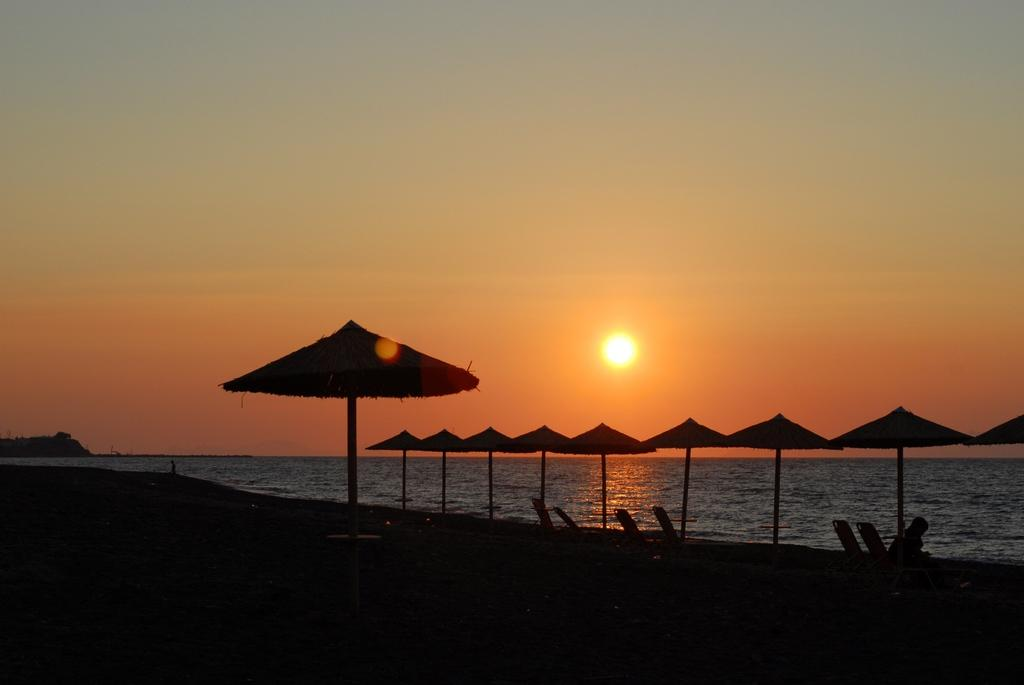What objects are present in the image that can provide shelter from the rain? There are umbrellas in the image that can provide shelter from the rain. What type of furniture is visible in the image? There are chairs in the image. Can you describe the person in the image? There is a person in the image. What can be seen in the background of the image? There is water visible in the background of the image. What is the weather like in the image? The sun is visible in the sky, suggesting a sunny day. What part of the natural environment is visible in the image? The sky is visible in the image. What type of afterthought is the person having while holding the umbrella in the image? There is no indication of any afterthoughts in the image; the person is simply holding an umbrella. Can you tell me what error the person made while setting up the umbrella in the image? There is no error visible in the image; the person is holding an umbrella correctly. 